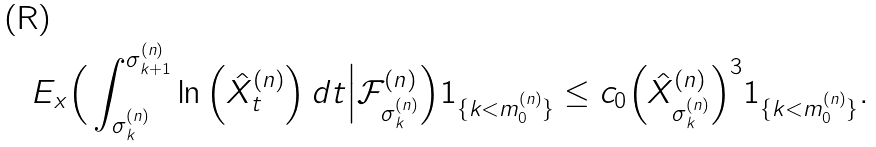Convert formula to latex. <formula><loc_0><loc_0><loc_500><loc_500>E _ { x } \Big ( \int _ { \sigma ^ { ( n ) } _ { k } } ^ { \sigma ^ { ( n ) } _ { k + 1 } } \ln \Big ( \hat { X } ^ { ( n ) } _ { t } \Big ) \, d t \Big | \mathcal { F } ^ { ( n ) } _ { \sigma ^ { ( n ) } _ { k } } \Big ) 1 _ { \{ k < m _ { 0 } ^ { ( n ) } \} } \leq c _ { 0 } \Big ( \hat { X } ^ { ( n ) } _ { \sigma ^ { ( n ) } _ { k } } \Big ) ^ { 3 } 1 _ { \{ k < m _ { 0 } ^ { ( n ) } \} } .</formula> 